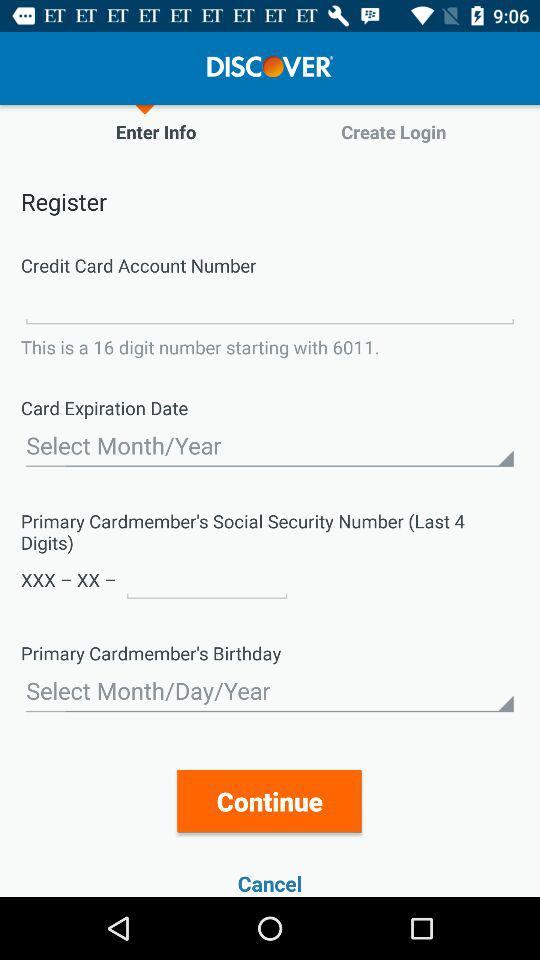How many digits are in the Social Security Number input field? The Social Security Number (SSN) input field typically requires entering 9 digits. However, in this specific context where only the last 4 digits are requested as indicated in the form, the input field will specifically hold these 4 digits. 